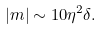<formula> <loc_0><loc_0><loc_500><loc_500>| m | \sim 1 0 \eta ^ { 2 } \delta .</formula> 